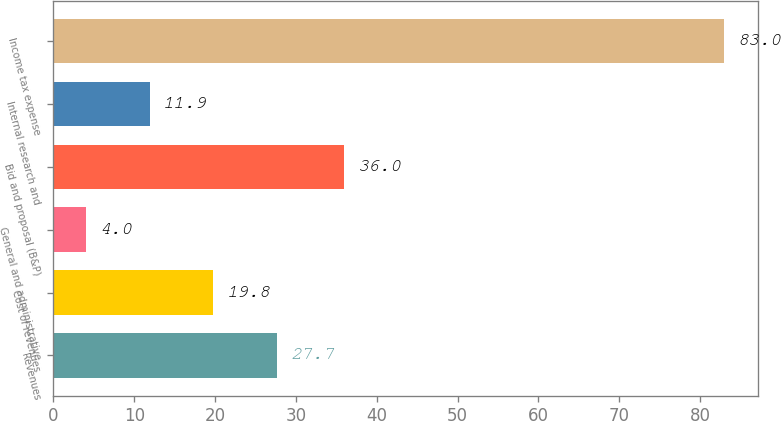Convert chart to OTSL. <chart><loc_0><loc_0><loc_500><loc_500><bar_chart><fcel>Revenues<fcel>Cost of revenues<fcel>General and administrative<fcel>Bid and proposal (B&P)<fcel>Internal research and<fcel>Income tax expense<nl><fcel>27.7<fcel>19.8<fcel>4<fcel>36<fcel>11.9<fcel>83<nl></chart> 